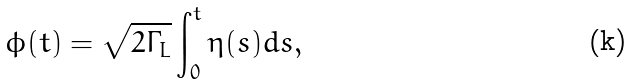<formula> <loc_0><loc_0><loc_500><loc_500>\phi ( t ) = \sqrt { 2 \Gamma _ { L } } \int _ { 0 } ^ { t } \eta ( s ) d s ,</formula> 